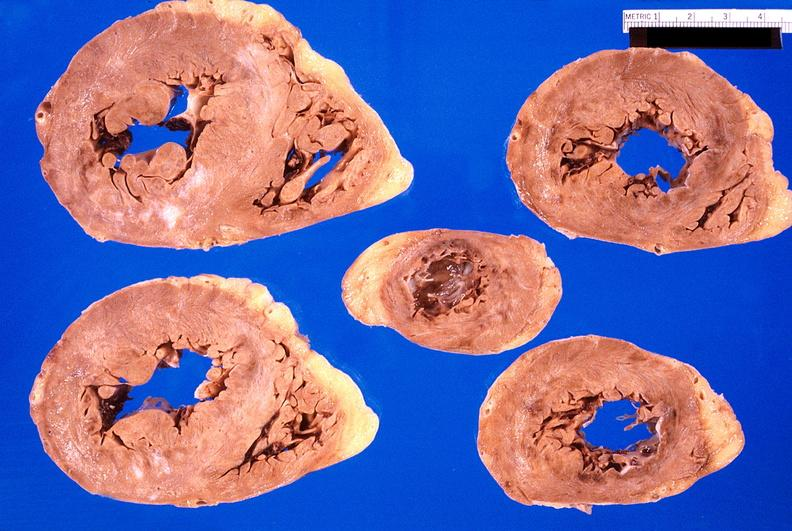does this image show heart, myocardial infarction free wall, 6 days old, in a patient with diabetes mellitus and hypertension?
Answer the question using a single word or phrase. Yes 